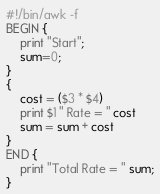<code> <loc_0><loc_0><loc_500><loc_500><_Awk_>#!/bin/awk -f
BEGIN {
	print "Start";
	sum=0;
}
{
	cost = ($3 * $4)
	print $1 " Rate = " cost
	sum = sum + cost
}
END {
	print "Total Rate = " sum;
}</code> 